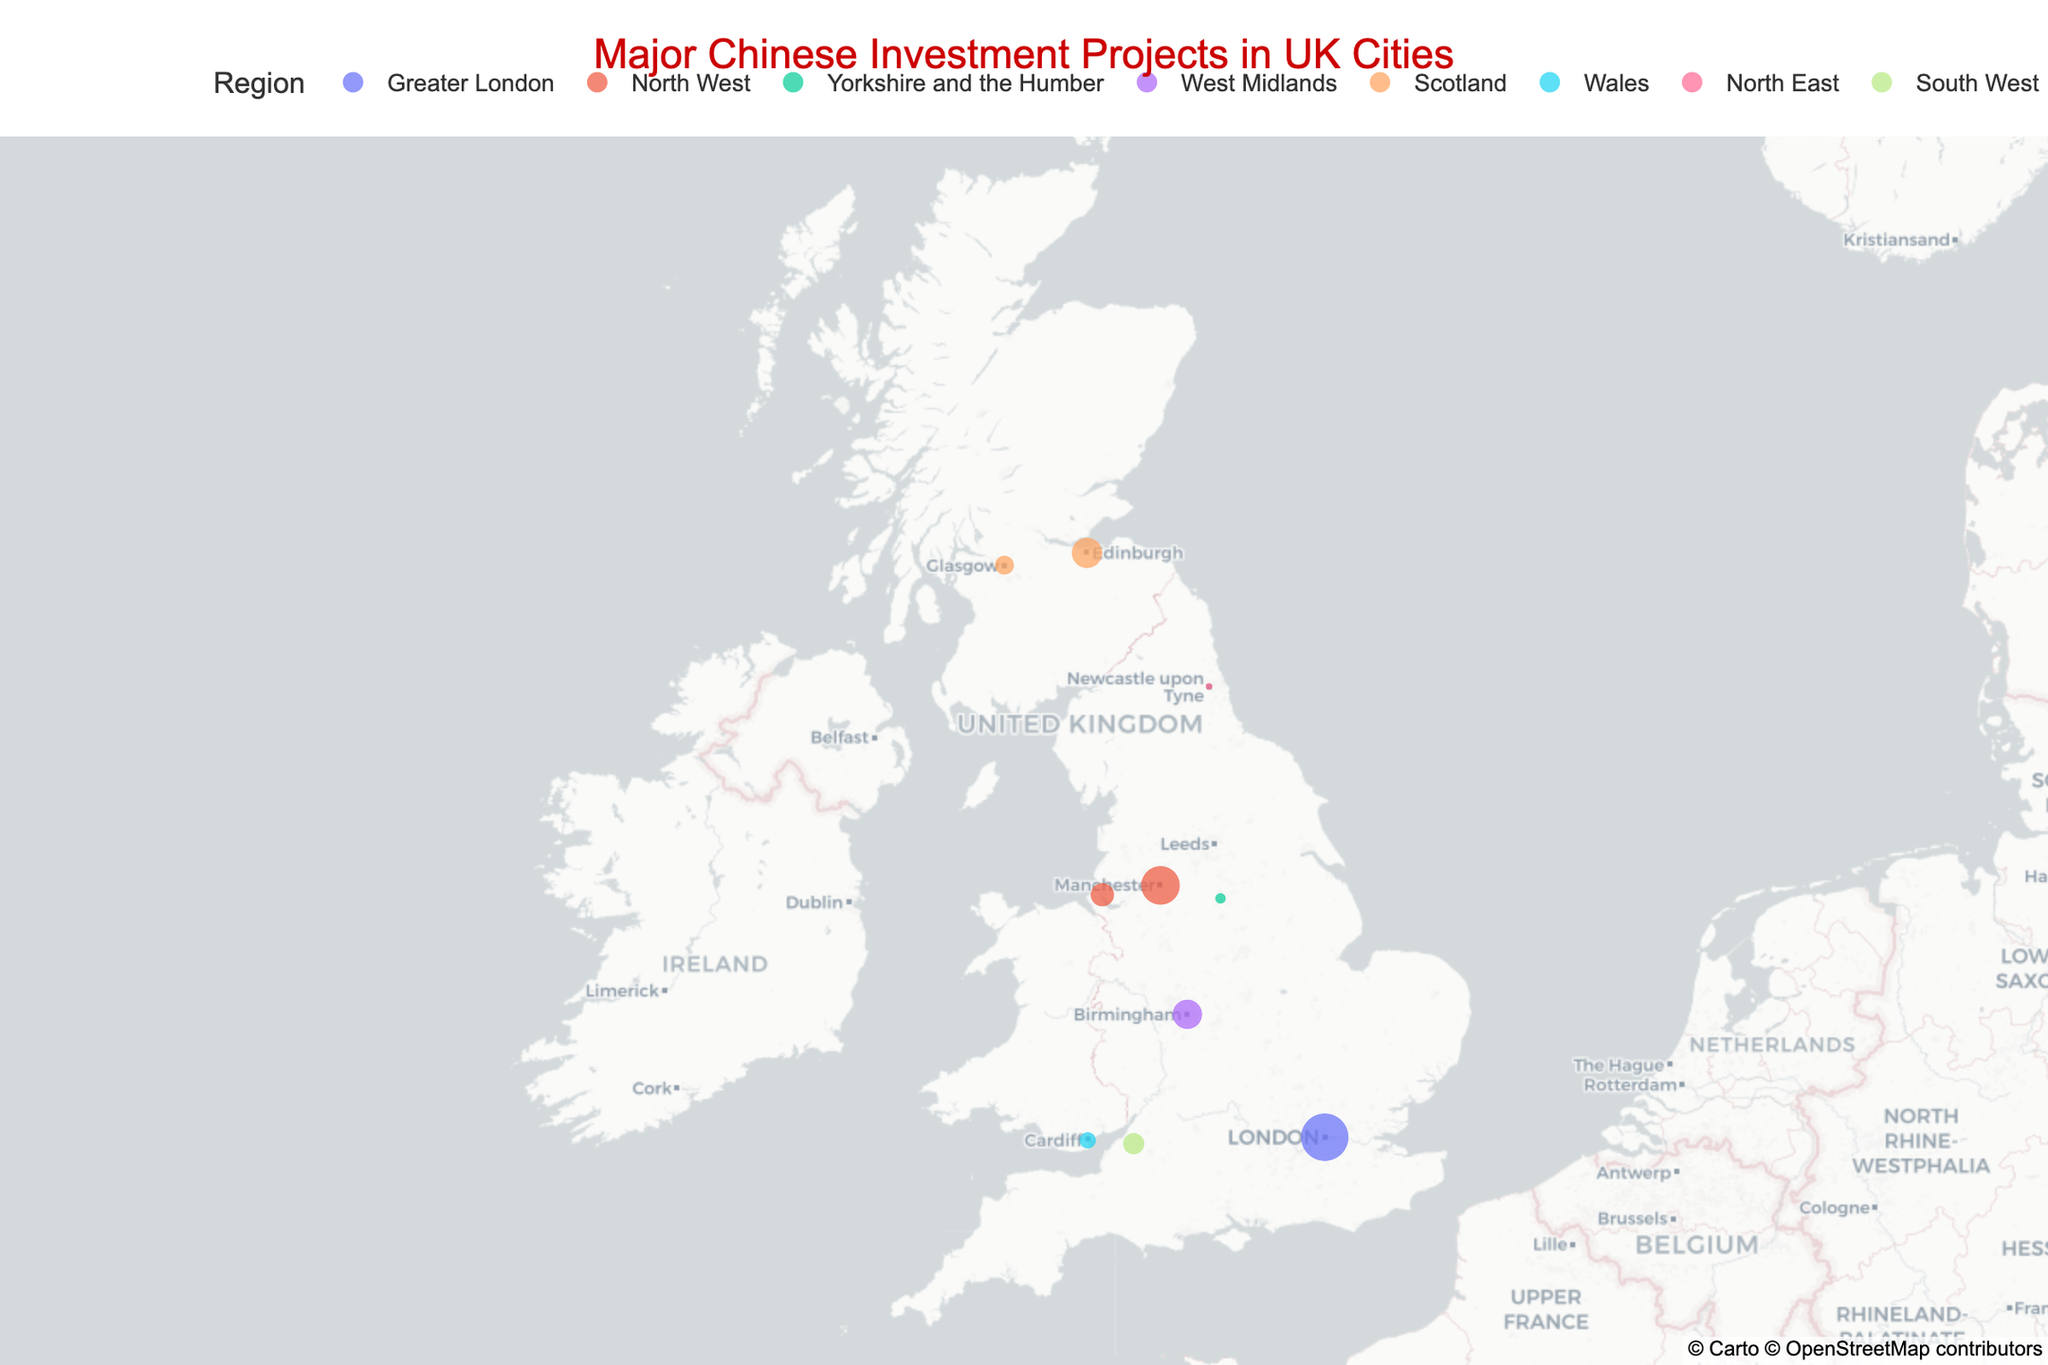What is the title of the figure? The title of the figure is prominently displayed at the top and should be clear and easy to read.
Answer: Major Chinese Investment Projects in UK Cities How many investment projects are shown on the figure? Count the number of distinct data points (circles) plotted on the map.
Answer: 10 Which city has the highest investment amount? Identify the city with the largest circle, as the size of the circle represents the investment amount.
Answer: London What is the total investment in the North West region? Add the investment amounts of all projects located in the North West region: Manchester (£800m) and Liverpool (£300m).
Answer: £1,100 million Which project in Scotland has a higher investment amount: Red Rock Power Wind Farm or CITIC Pacific Special Steel Plant? Compare the investment amounts of the two projects located in Scotland: Red Rock Power Wind Farm (£500m) in Edinburgh and CITIC Pacific Special Steel Plant (£200m) in Glasgow.
Answer: Red Rock Power Wind Farm What region has the most diverse range of cities with investment projects? Identify the region that has the most different cities with investment projects, counting each city in each region.
Answer: Scotland What color represents the investment projects in Greater London? Look at the color legend and find the color associated with Greater London.
Answer: Black How many regions have more than one city with investment projects? Count the number of regions where there is more than one distinct city with investment projects. Only the North West and Scotland have multiple cities with projects.
Answer: 2 Which city is located furthest north on the map? Locate the city with the highest latitude value on the map.
Answer: Edinburgh What is the average investment amount across all the projects listed? Sum the investment amounts of all the projects, then divide by the number of projects: (1200 + 800 + 65 + 470 + 500 + 150 + 300 + 30 + 250 + 200) / 10.
Answer: £396.5 million 